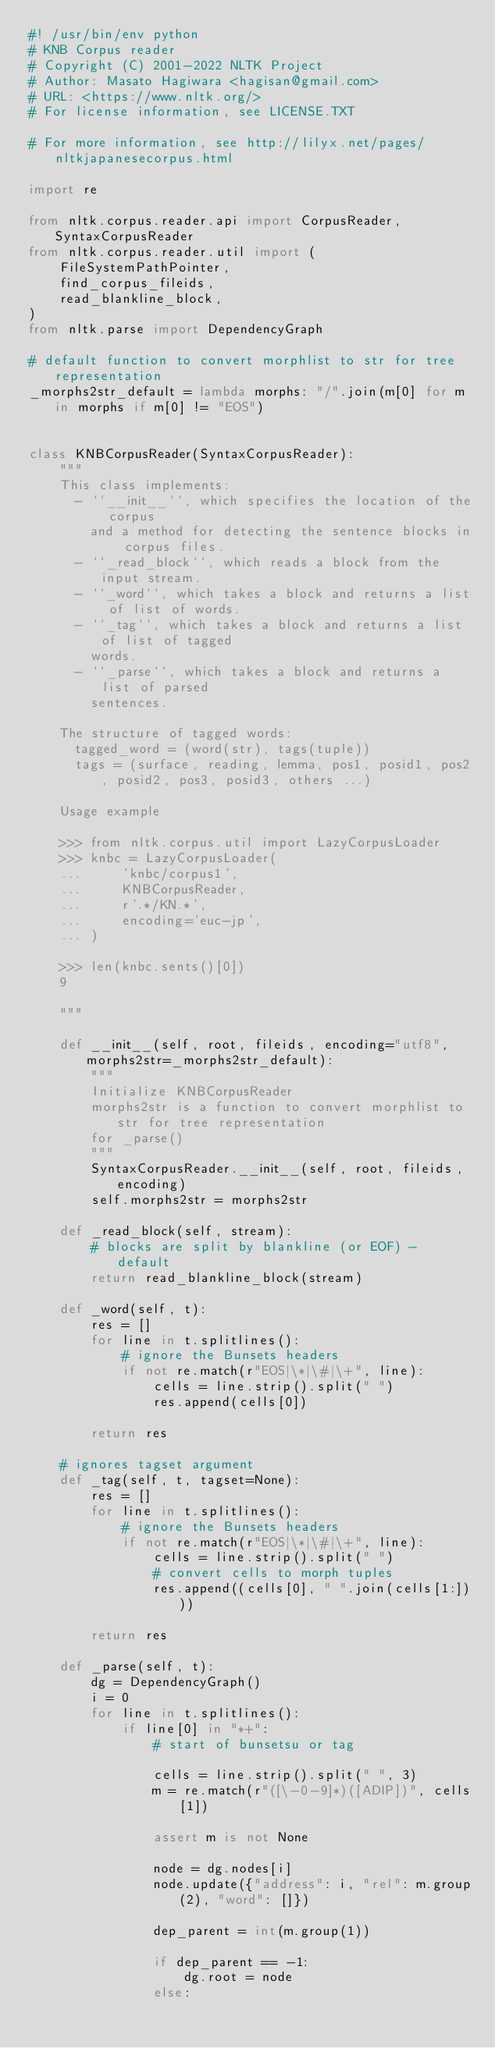<code> <loc_0><loc_0><loc_500><loc_500><_Python_>#! /usr/bin/env python
# KNB Corpus reader
# Copyright (C) 2001-2022 NLTK Project
# Author: Masato Hagiwara <hagisan@gmail.com>
# URL: <https://www.nltk.org/>
# For license information, see LICENSE.TXT

# For more information, see http://lilyx.net/pages/nltkjapanesecorpus.html

import re

from nltk.corpus.reader.api import CorpusReader, SyntaxCorpusReader
from nltk.corpus.reader.util import (
    FileSystemPathPointer,
    find_corpus_fileids,
    read_blankline_block,
)
from nltk.parse import DependencyGraph

# default function to convert morphlist to str for tree representation
_morphs2str_default = lambda morphs: "/".join(m[0] for m in morphs if m[0] != "EOS")


class KNBCorpusReader(SyntaxCorpusReader):
    """
    This class implements:
      - ``__init__``, which specifies the location of the corpus
        and a method for detecting the sentence blocks in corpus files.
      - ``_read_block``, which reads a block from the input stream.
      - ``_word``, which takes a block and returns a list of list of words.
      - ``_tag``, which takes a block and returns a list of list of tagged
        words.
      - ``_parse``, which takes a block and returns a list of parsed
        sentences.

    The structure of tagged words:
      tagged_word = (word(str), tags(tuple))
      tags = (surface, reading, lemma, pos1, posid1, pos2, posid2, pos3, posid3, others ...)

    Usage example

    >>> from nltk.corpus.util import LazyCorpusLoader
    >>> knbc = LazyCorpusLoader(
    ...     'knbc/corpus1',
    ...     KNBCorpusReader,
    ...     r'.*/KN.*',
    ...     encoding='euc-jp',
    ... )

    >>> len(knbc.sents()[0])
    9

    """

    def __init__(self, root, fileids, encoding="utf8", morphs2str=_morphs2str_default):
        """
        Initialize KNBCorpusReader
        morphs2str is a function to convert morphlist to str for tree representation
        for _parse()
        """
        SyntaxCorpusReader.__init__(self, root, fileids, encoding)
        self.morphs2str = morphs2str

    def _read_block(self, stream):
        # blocks are split by blankline (or EOF) - default
        return read_blankline_block(stream)

    def _word(self, t):
        res = []
        for line in t.splitlines():
            # ignore the Bunsets headers
            if not re.match(r"EOS|\*|\#|\+", line):
                cells = line.strip().split(" ")
                res.append(cells[0])

        return res

    # ignores tagset argument
    def _tag(self, t, tagset=None):
        res = []
        for line in t.splitlines():
            # ignore the Bunsets headers
            if not re.match(r"EOS|\*|\#|\+", line):
                cells = line.strip().split(" ")
                # convert cells to morph tuples
                res.append((cells[0], " ".join(cells[1:])))

        return res

    def _parse(self, t):
        dg = DependencyGraph()
        i = 0
        for line in t.splitlines():
            if line[0] in "*+":
                # start of bunsetsu or tag

                cells = line.strip().split(" ", 3)
                m = re.match(r"([\-0-9]*)([ADIP])", cells[1])

                assert m is not None

                node = dg.nodes[i]
                node.update({"address": i, "rel": m.group(2), "word": []})

                dep_parent = int(m.group(1))

                if dep_parent == -1:
                    dg.root = node
                else:</code> 